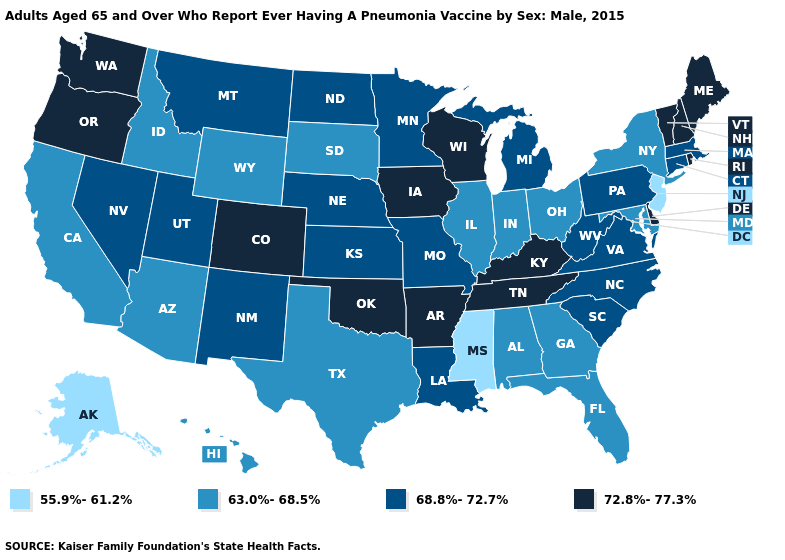What is the lowest value in states that border Texas?
Be succinct. 68.8%-72.7%. What is the highest value in the MidWest ?
Quick response, please. 72.8%-77.3%. What is the lowest value in states that border Maryland?
Concise answer only. 68.8%-72.7%. Which states hav the highest value in the West?
Be succinct. Colorado, Oregon, Washington. What is the value of Nevada?
Concise answer only. 68.8%-72.7%. Among the states that border North Dakota , does Minnesota have the lowest value?
Be succinct. No. Does New Jersey have the highest value in the Northeast?
Short answer required. No. What is the value of Delaware?
Write a very short answer. 72.8%-77.3%. Does Washington have the highest value in the USA?
Write a very short answer. Yes. Name the states that have a value in the range 72.8%-77.3%?
Give a very brief answer. Arkansas, Colorado, Delaware, Iowa, Kentucky, Maine, New Hampshire, Oklahoma, Oregon, Rhode Island, Tennessee, Vermont, Washington, Wisconsin. What is the lowest value in the USA?
Write a very short answer. 55.9%-61.2%. What is the lowest value in the USA?
Short answer required. 55.9%-61.2%. Name the states that have a value in the range 55.9%-61.2%?
Be succinct. Alaska, Mississippi, New Jersey. Does Colorado have the highest value in the USA?
Concise answer only. Yes. What is the value of Oklahoma?
Quick response, please. 72.8%-77.3%. 